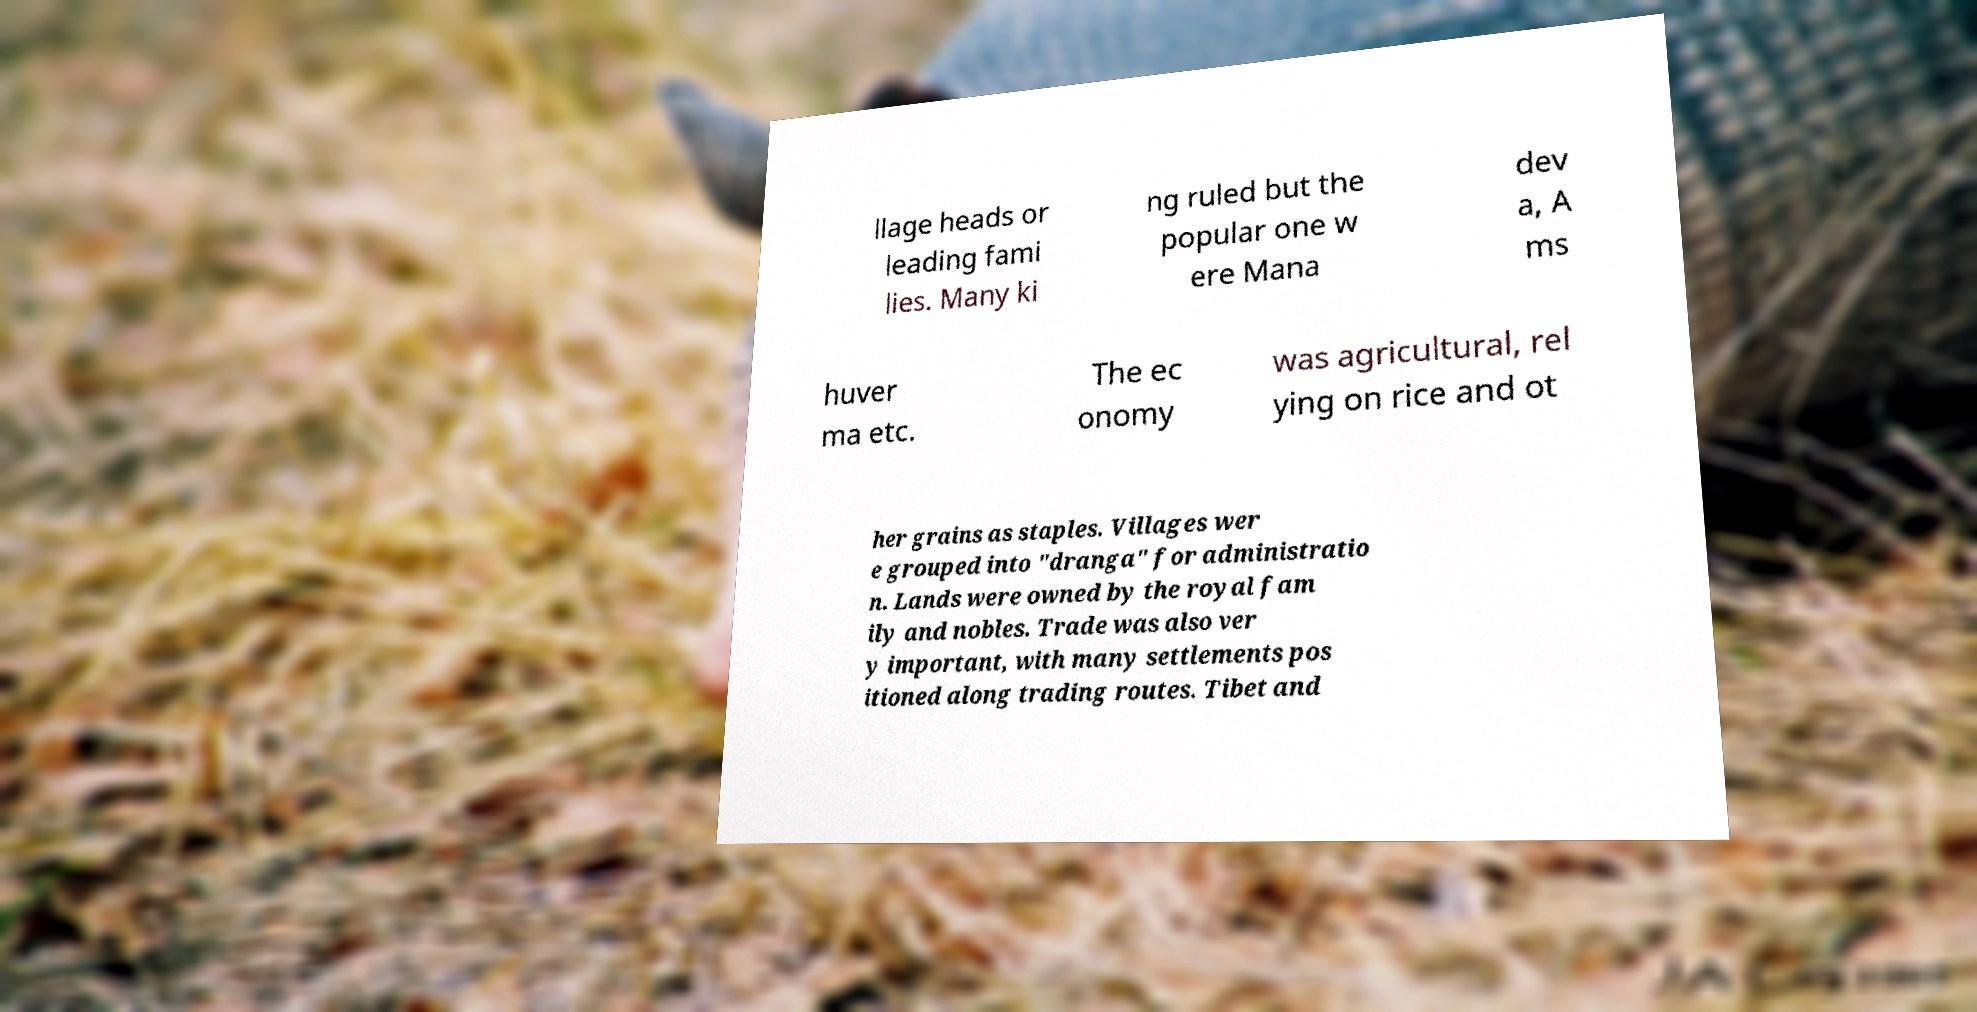For documentation purposes, I need the text within this image transcribed. Could you provide that? llage heads or leading fami lies. Many ki ng ruled but the popular one w ere Mana dev a, A ms huver ma etc. The ec onomy was agricultural, rel ying on rice and ot her grains as staples. Villages wer e grouped into "dranga" for administratio n. Lands were owned by the royal fam ily and nobles. Trade was also ver y important, with many settlements pos itioned along trading routes. Tibet and 